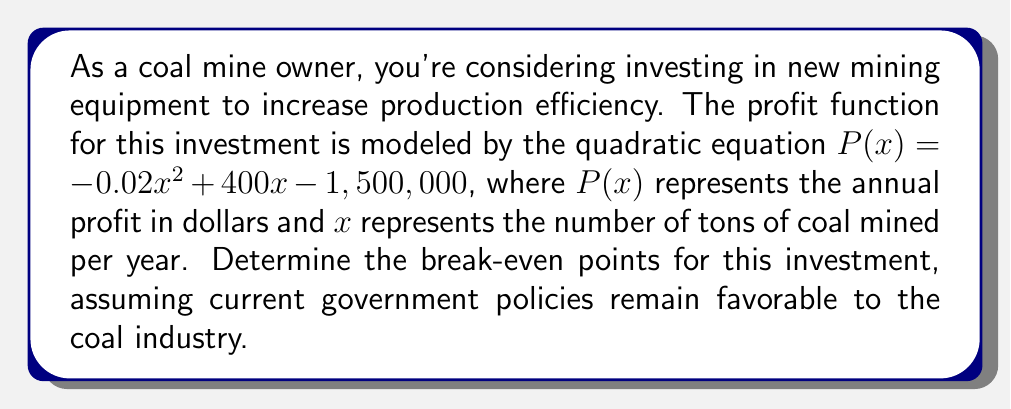Help me with this question. To find the break-even points, we need to solve the equation $P(x) = 0$:

1) Set up the equation:
   $-0.02x^2 + 400x - 1,500,000 = 0$

2) This is a quadratic equation in the form $ax^2 + bx + c = 0$, where:
   $a = -0.02$
   $b = 400$
   $c = -1,500,000$

3) We can solve this using the quadratic formula: $x = \frac{-b \pm \sqrt{b^2 - 4ac}}{2a}$

4) Substitute the values:
   $x = \frac{-400 \pm \sqrt{400^2 - 4(-0.02)(-1,500,000)}}{2(-0.02)}$

5) Simplify under the square root:
   $x = \frac{-400 \pm \sqrt{160,000 + 120,000}}{-0.04}$
   $x = \frac{-400 \pm \sqrt{280,000}}{-0.04}$

6) Calculate the square root:
   $x = \frac{-400 \pm 529.15}{-0.04}$

7) Solve for both possibilities:
   $x_1 = \frac{-400 + 529.15}{-0.04} \approx 3,228.75$
   $x_2 = \frac{-400 - 529.15}{-0.04} \approx 23,228.75$

8) Round to the nearest whole number, as we can't mine partial tons:
   $x_1 = 3,229$ tons
   $x_2 = 23,229$ tons

These are the two break-even points. The investment will be profitable when annual production is between these two values.
Answer: 3,229 tons and 23,229 tons 